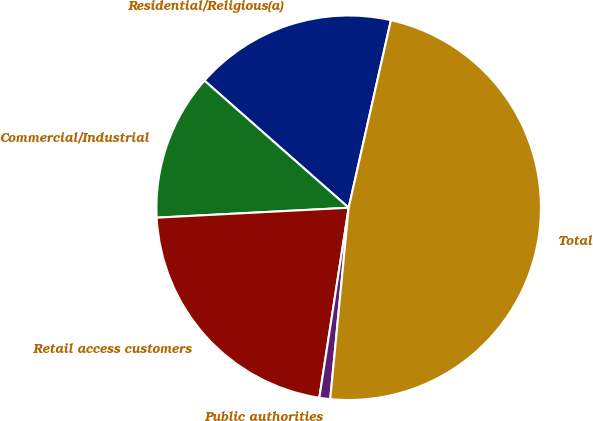Convert chart. <chart><loc_0><loc_0><loc_500><loc_500><pie_chart><fcel>Residential/Religious(a)<fcel>Commercial/Industrial<fcel>Retail access customers<fcel>Public authorities<fcel>Total<nl><fcel>17.03%<fcel>12.32%<fcel>21.74%<fcel>0.91%<fcel>48.01%<nl></chart> 